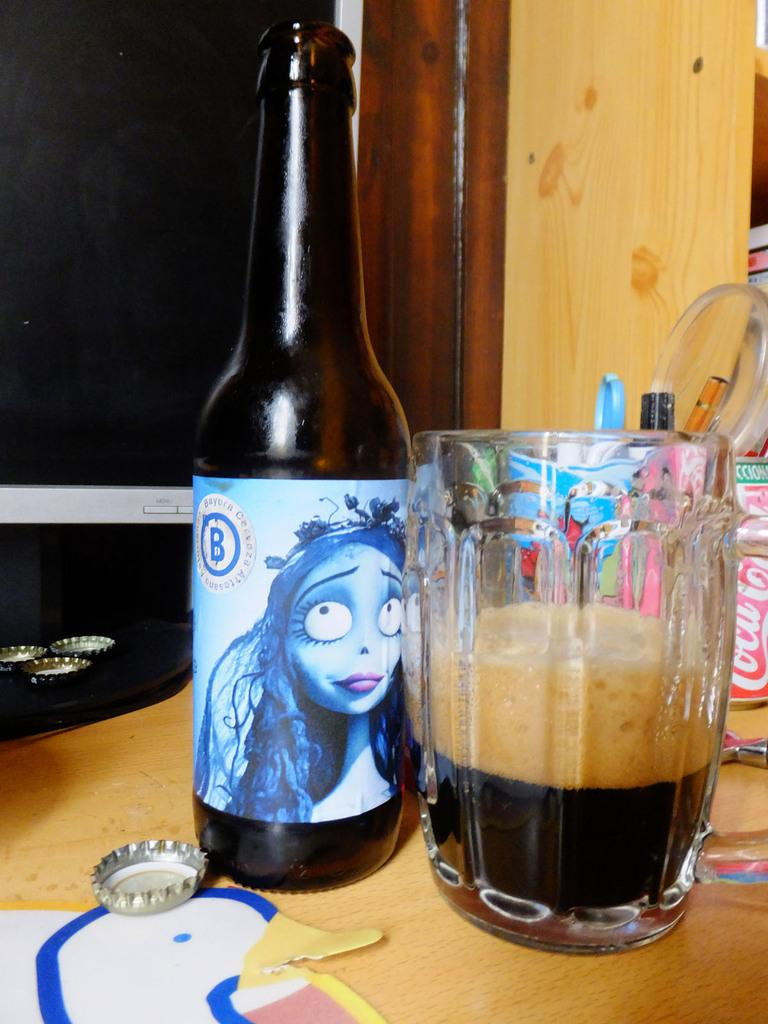Provide a one-sentence caption for the provided image. Assorted beverages on a table including a beer bottle labeled B and a Coca Cola can. 